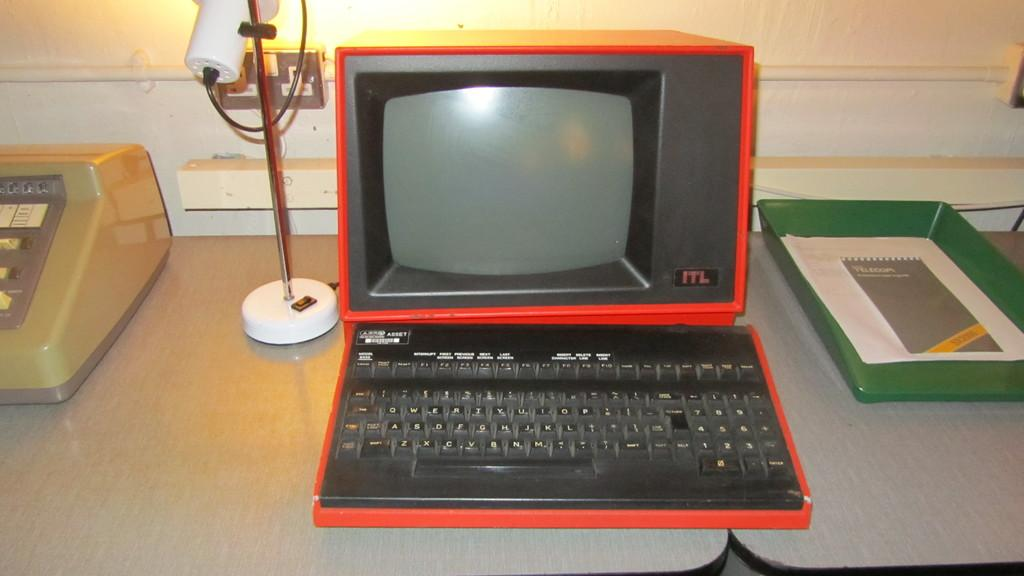<image>
Offer a succinct explanation of the picture presented. An old red computer that says ITL in the corner. 